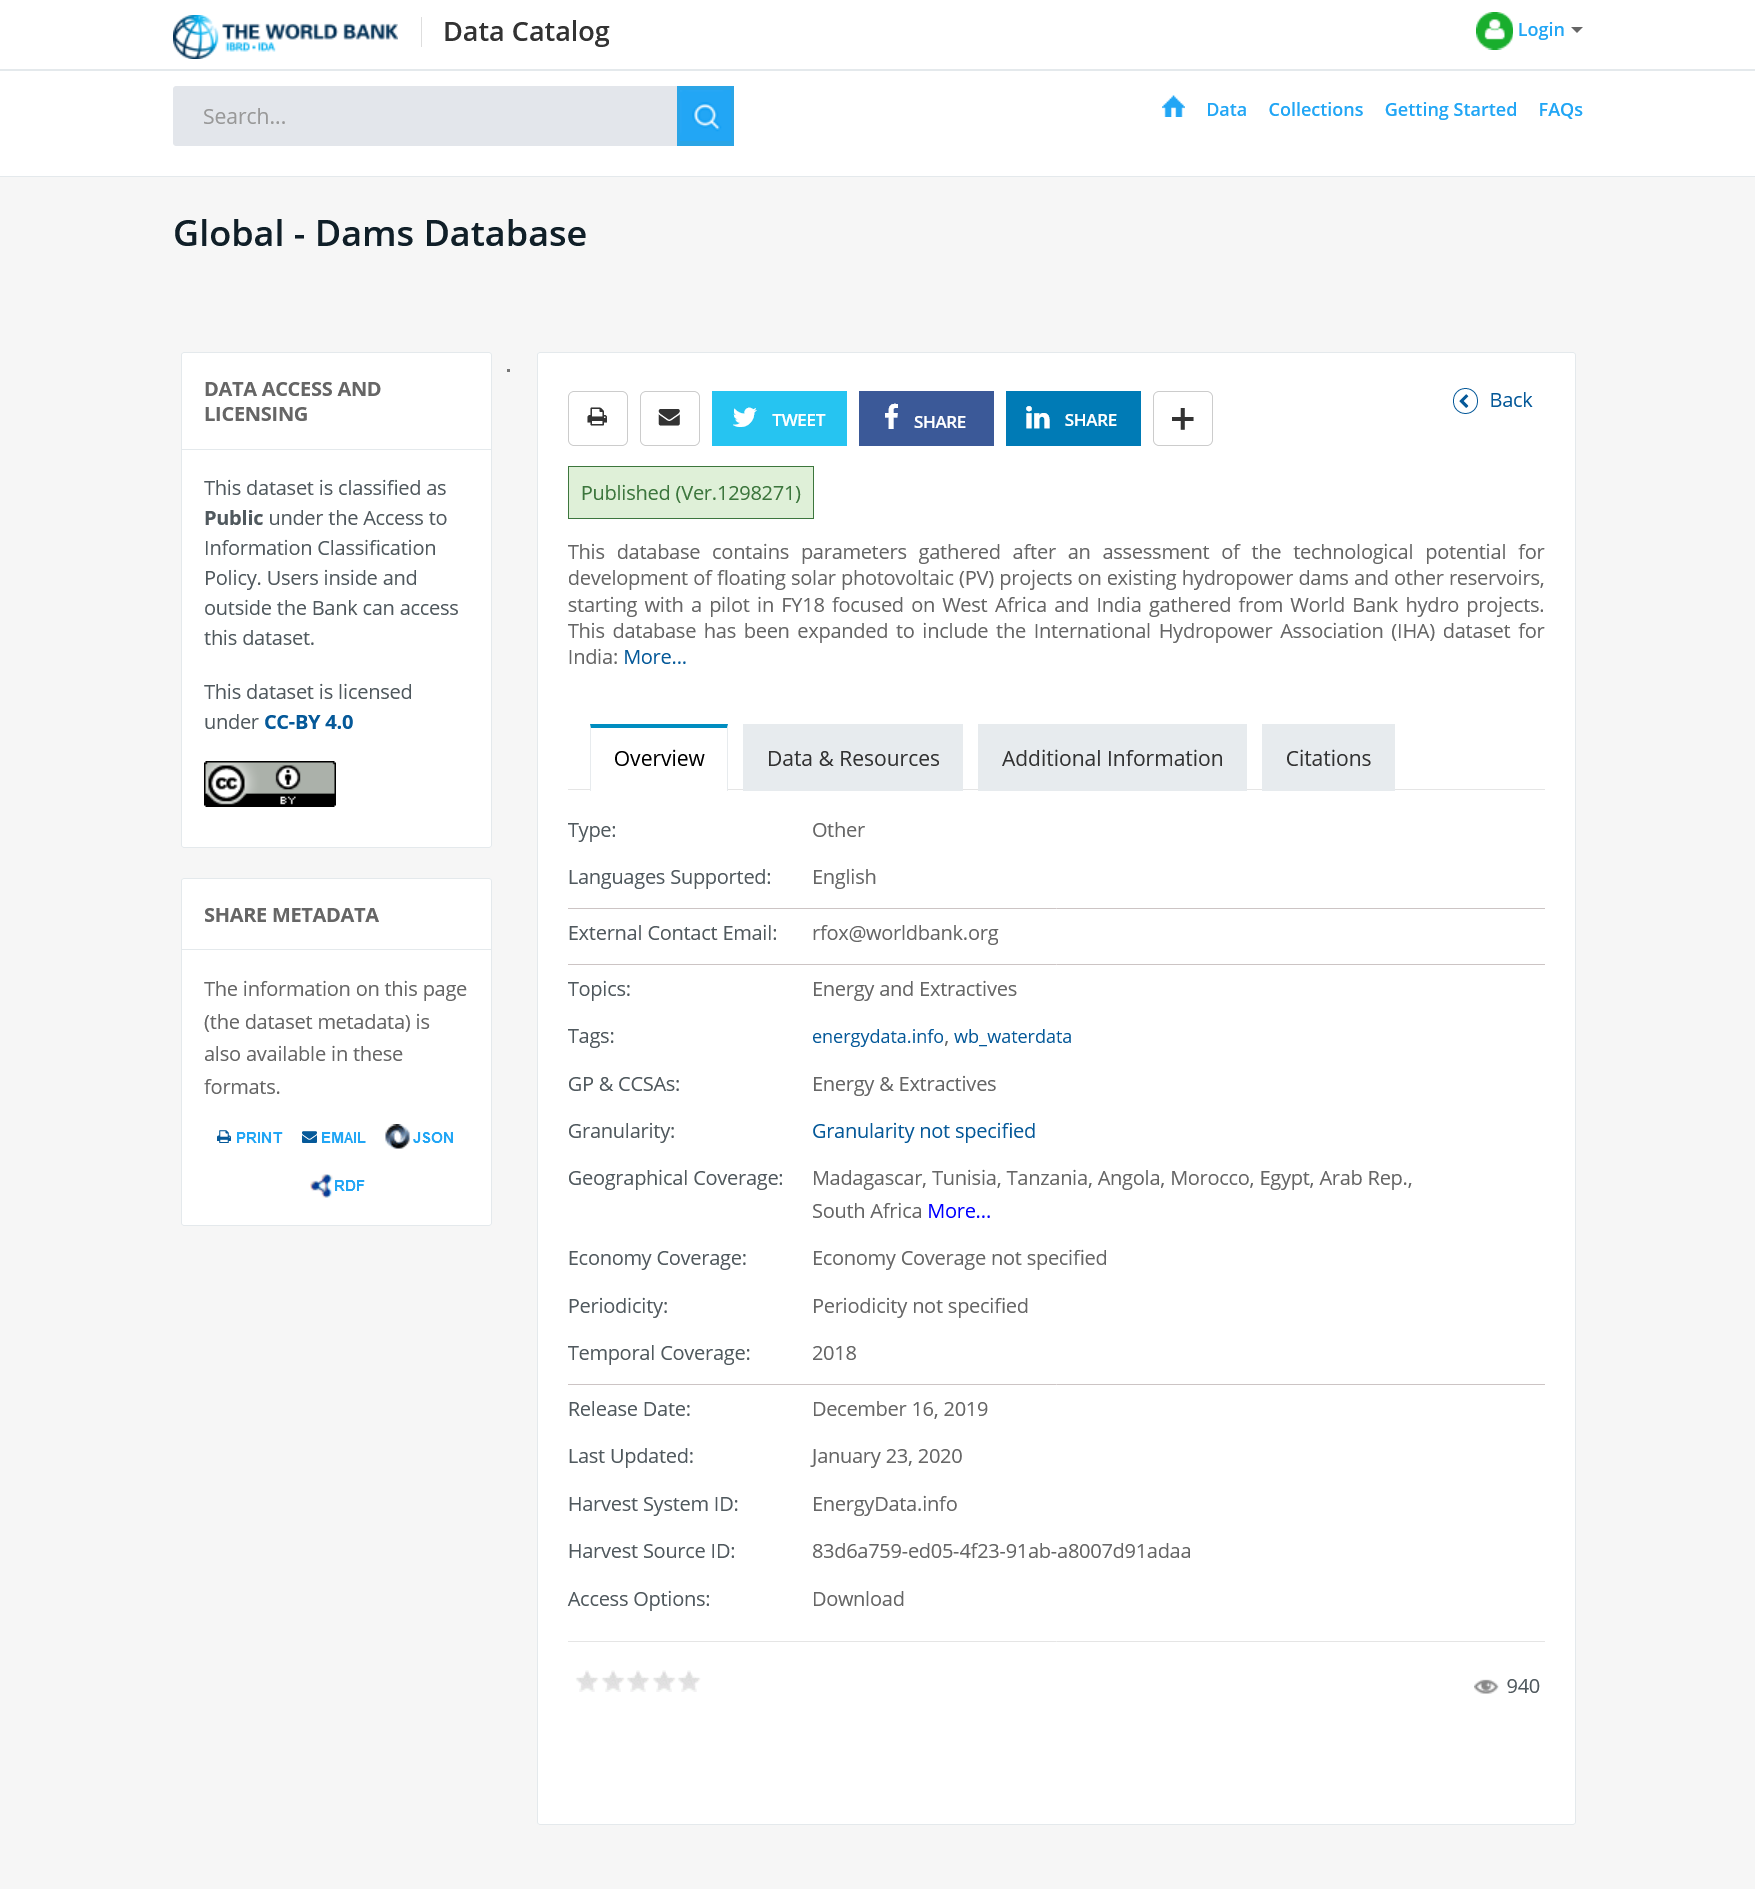List a handful of essential elements in this visual. The database contains information on dams. This content is publicly available and accessible without restriction or licensing fees. The content can be shared freely on social media without any restrictions. 